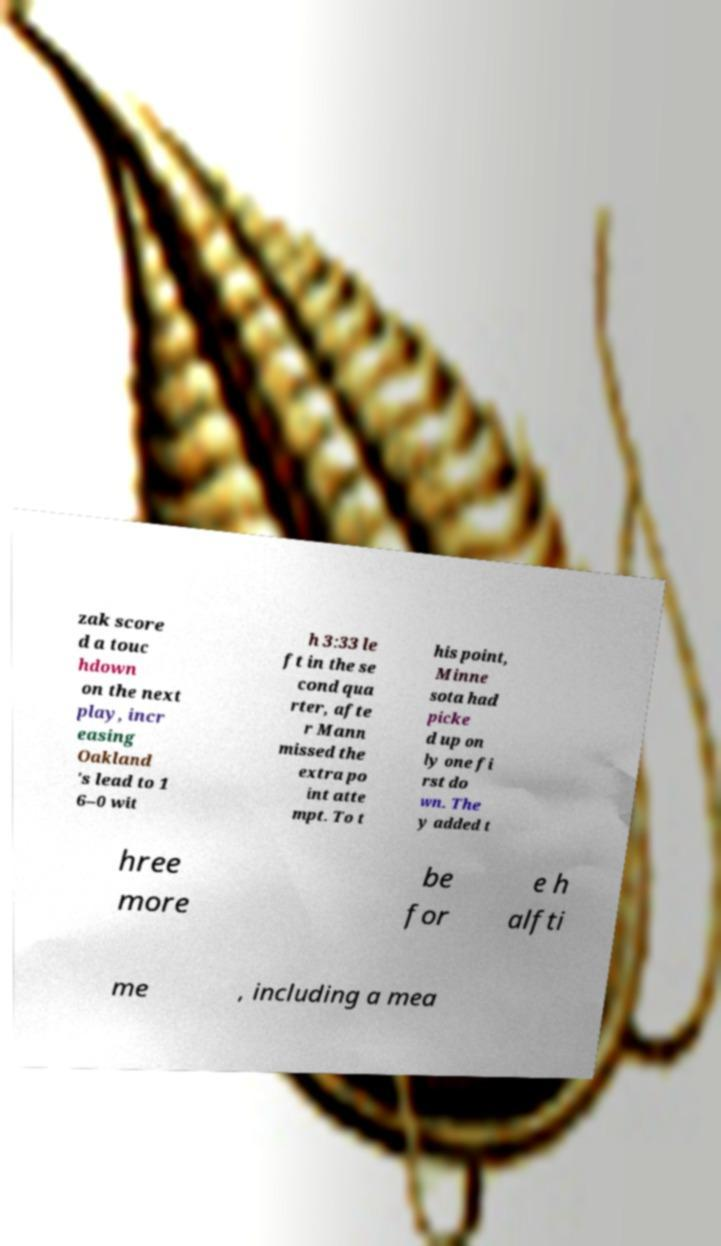There's text embedded in this image that I need extracted. Can you transcribe it verbatim? zak score d a touc hdown on the next play, incr easing Oakland 's lead to 1 6–0 wit h 3:33 le ft in the se cond qua rter, afte r Mann missed the extra po int atte mpt. To t his point, Minne sota had picke d up on ly one fi rst do wn. The y added t hree more be for e h alfti me , including a mea 